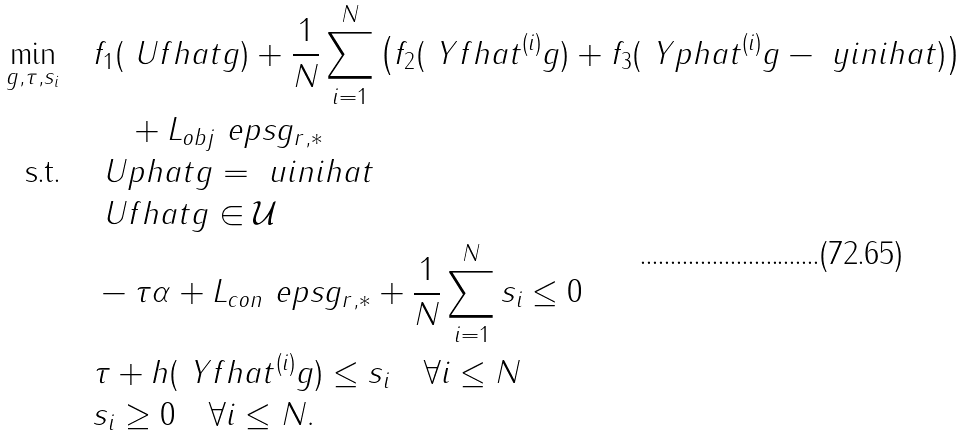<formula> <loc_0><loc_0><loc_500><loc_500>\underset { g , \tau , s _ { i } } { \min } \quad & f _ { 1 } ( \ U f h a t g ) + \frac { 1 } { N } \sum _ { i = 1 } ^ { N } \left ( f _ { 2 } ( \ Y f h a t ^ { ( i ) } g ) + f _ { 3 } ( \ Y p h a t ^ { ( i ) } g - \ y i n i h a t ) \right ) \\ & \quad + L _ { o b j } \ e p s \| g \| _ { r , \ast } \\ \text {s.t.\quad} & \ U p h a t g = \ u i n i h a t \\ & \ U f h a t g \in \mathcal { U } \\ & - \tau \alpha + L _ { c o n } \ e p s \| g \| _ { r , \ast } + \frac { 1 } { N } \sum _ { i = 1 } ^ { N } s _ { i } \leq 0 \\ & \tau + h ( \ Y f h a t ^ { ( i ) } g ) \leq s _ { i } \quad \forall i \leq N \\ & s _ { i } \geq 0 \quad \forall i \leq N .</formula> 